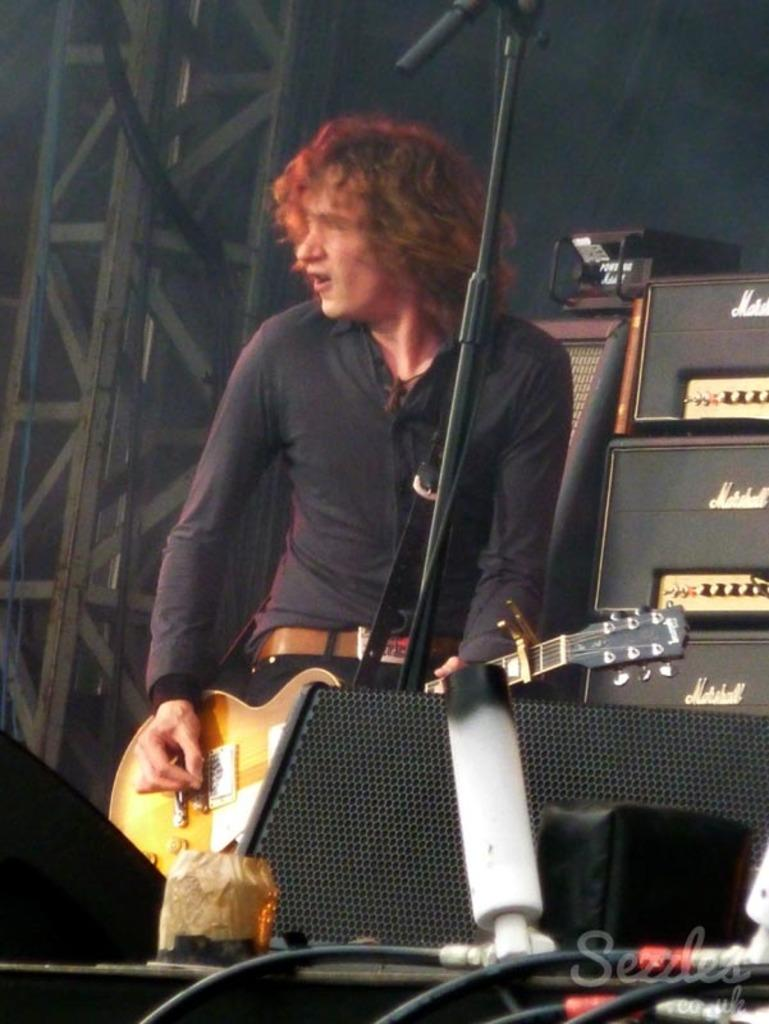What is the person in the image doing? The person is playing a musical instrument in the image. What is used to amplify the sound of the musical instrument? There is a sound system in the image. What connects the sound system to the musical instrument? Wires are visible in the image. How many oranges are on the table next to the person playing the musical instrument? There are no oranges present in the image. 